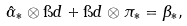<formula> <loc_0><loc_0><loc_500><loc_500>\hat { \alpha } _ { * } \otimes \i d + \i d \otimes \pi _ { * } = \beta _ { * } ,</formula> 